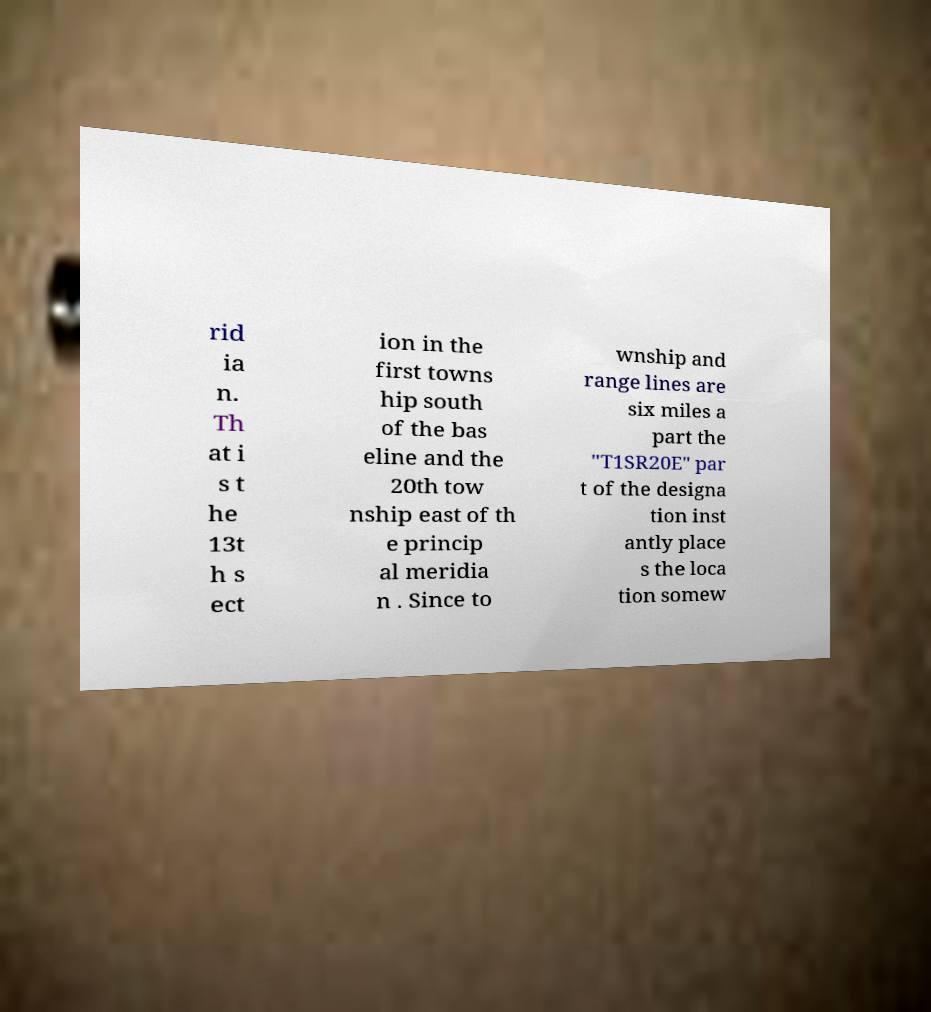There's text embedded in this image that I need extracted. Can you transcribe it verbatim? rid ia n. Th at i s t he 13t h s ect ion in the first towns hip south of the bas eline and the 20th tow nship east of th e princip al meridia n . Since to wnship and range lines are six miles a part the "T1SR20E" par t of the designa tion inst antly place s the loca tion somew 